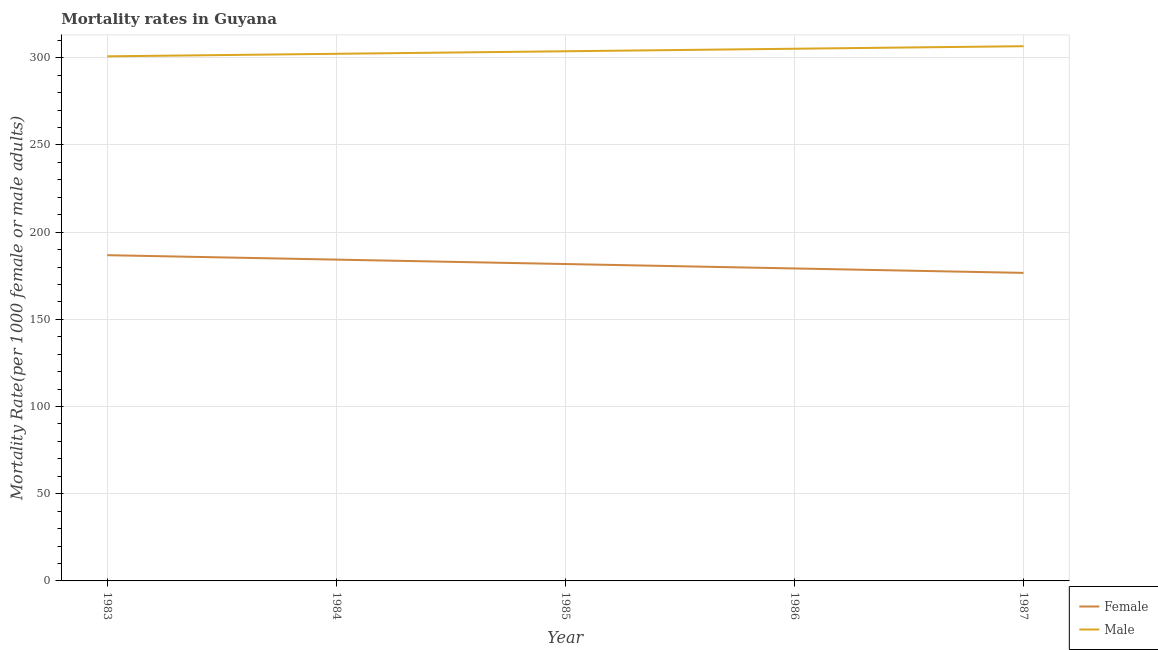How many different coloured lines are there?
Offer a terse response. 2. Is the number of lines equal to the number of legend labels?
Give a very brief answer. Yes. What is the male mortality rate in 1984?
Provide a short and direct response. 302.26. Across all years, what is the maximum male mortality rate?
Provide a succinct answer. 306.62. Across all years, what is the minimum female mortality rate?
Ensure brevity in your answer.  176.64. In which year was the male mortality rate maximum?
Keep it short and to the point. 1987. In which year was the female mortality rate minimum?
Give a very brief answer. 1987. What is the total male mortality rate in the graph?
Your answer should be compact. 1518.56. What is the difference between the female mortality rate in 1984 and that in 1985?
Your response must be concise. 2.53. What is the difference between the male mortality rate in 1984 and the female mortality rate in 1987?
Ensure brevity in your answer.  125.62. What is the average female mortality rate per year?
Your response must be concise. 181.71. In the year 1985, what is the difference between the male mortality rate and female mortality rate?
Keep it short and to the point. 122. What is the ratio of the male mortality rate in 1983 to that in 1985?
Your answer should be very brief. 0.99. Is the difference between the male mortality rate in 1983 and 1987 greater than the difference between the female mortality rate in 1983 and 1987?
Give a very brief answer. No. What is the difference between the highest and the second highest female mortality rate?
Your answer should be very brief. 2.53. What is the difference between the highest and the lowest male mortality rate?
Your answer should be very brief. 5.81. In how many years, is the female mortality rate greater than the average female mortality rate taken over all years?
Offer a very short reply. 3. Does the female mortality rate monotonically increase over the years?
Offer a very short reply. No. How many years are there in the graph?
Keep it short and to the point. 5. Are the values on the major ticks of Y-axis written in scientific E-notation?
Ensure brevity in your answer.  No. Does the graph contain any zero values?
Your response must be concise. No. Does the graph contain grids?
Offer a very short reply. Yes. How are the legend labels stacked?
Your answer should be very brief. Vertical. What is the title of the graph?
Keep it short and to the point. Mortality rates in Guyana. What is the label or title of the X-axis?
Keep it short and to the point. Year. What is the label or title of the Y-axis?
Offer a very short reply. Mortality Rate(per 1000 female or male adults). What is the Mortality Rate(per 1000 female or male adults) of Female in 1983?
Your answer should be compact. 186.78. What is the Mortality Rate(per 1000 female or male adults) of Male in 1983?
Your answer should be very brief. 300.81. What is the Mortality Rate(per 1000 female or male adults) in Female in 1984?
Make the answer very short. 184.25. What is the Mortality Rate(per 1000 female or male adults) of Male in 1984?
Offer a terse response. 302.26. What is the Mortality Rate(per 1000 female or male adults) in Female in 1985?
Keep it short and to the point. 181.71. What is the Mortality Rate(per 1000 female or male adults) in Male in 1985?
Offer a very short reply. 303.71. What is the Mortality Rate(per 1000 female or male adults) in Female in 1986?
Provide a succinct answer. 179.18. What is the Mortality Rate(per 1000 female or male adults) in Male in 1986?
Your response must be concise. 305.17. What is the Mortality Rate(per 1000 female or male adults) of Female in 1987?
Make the answer very short. 176.64. What is the Mortality Rate(per 1000 female or male adults) of Male in 1987?
Provide a succinct answer. 306.62. Across all years, what is the maximum Mortality Rate(per 1000 female or male adults) in Female?
Keep it short and to the point. 186.78. Across all years, what is the maximum Mortality Rate(per 1000 female or male adults) in Male?
Keep it short and to the point. 306.62. Across all years, what is the minimum Mortality Rate(per 1000 female or male adults) of Female?
Provide a succinct answer. 176.64. Across all years, what is the minimum Mortality Rate(per 1000 female or male adults) in Male?
Offer a terse response. 300.81. What is the total Mortality Rate(per 1000 female or male adults) in Female in the graph?
Provide a succinct answer. 908.56. What is the total Mortality Rate(per 1000 female or male adults) of Male in the graph?
Your answer should be compact. 1518.56. What is the difference between the Mortality Rate(per 1000 female or male adults) in Female in 1983 and that in 1984?
Provide a succinct answer. 2.53. What is the difference between the Mortality Rate(per 1000 female or male adults) of Male in 1983 and that in 1984?
Your response must be concise. -1.45. What is the difference between the Mortality Rate(per 1000 female or male adults) in Female in 1983 and that in 1985?
Provide a short and direct response. 5.07. What is the difference between the Mortality Rate(per 1000 female or male adults) of Male in 1983 and that in 1985?
Your answer should be very brief. -2.9. What is the difference between the Mortality Rate(per 1000 female or male adults) of Female in 1983 and that in 1986?
Give a very brief answer. 7.6. What is the difference between the Mortality Rate(per 1000 female or male adults) in Male in 1983 and that in 1986?
Provide a succinct answer. -4.36. What is the difference between the Mortality Rate(per 1000 female or male adults) in Female in 1983 and that in 1987?
Provide a short and direct response. 10.14. What is the difference between the Mortality Rate(per 1000 female or male adults) of Male in 1983 and that in 1987?
Your answer should be compact. -5.81. What is the difference between the Mortality Rate(per 1000 female or male adults) of Female in 1984 and that in 1985?
Provide a short and direct response. 2.53. What is the difference between the Mortality Rate(per 1000 female or male adults) in Male in 1984 and that in 1985?
Make the answer very short. -1.45. What is the difference between the Mortality Rate(per 1000 female or male adults) in Female in 1984 and that in 1986?
Provide a succinct answer. 5.07. What is the difference between the Mortality Rate(per 1000 female or male adults) in Male in 1984 and that in 1986?
Provide a succinct answer. -2.9. What is the difference between the Mortality Rate(per 1000 female or male adults) of Female in 1984 and that in 1987?
Your answer should be very brief. 7.6. What is the difference between the Mortality Rate(per 1000 female or male adults) in Male in 1984 and that in 1987?
Provide a short and direct response. -4.36. What is the difference between the Mortality Rate(per 1000 female or male adults) of Female in 1985 and that in 1986?
Offer a very short reply. 2.54. What is the difference between the Mortality Rate(per 1000 female or male adults) of Male in 1985 and that in 1986?
Provide a succinct answer. -1.45. What is the difference between the Mortality Rate(per 1000 female or male adults) of Female in 1985 and that in 1987?
Offer a terse response. 5.07. What is the difference between the Mortality Rate(per 1000 female or male adults) of Male in 1985 and that in 1987?
Ensure brevity in your answer.  -2.9. What is the difference between the Mortality Rate(per 1000 female or male adults) in Female in 1986 and that in 1987?
Your answer should be very brief. 2.53. What is the difference between the Mortality Rate(per 1000 female or male adults) of Male in 1986 and that in 1987?
Make the answer very short. -1.45. What is the difference between the Mortality Rate(per 1000 female or male adults) of Female in 1983 and the Mortality Rate(per 1000 female or male adults) of Male in 1984?
Make the answer very short. -115.48. What is the difference between the Mortality Rate(per 1000 female or male adults) in Female in 1983 and the Mortality Rate(per 1000 female or male adults) in Male in 1985?
Your answer should be compact. -116.93. What is the difference between the Mortality Rate(per 1000 female or male adults) of Female in 1983 and the Mortality Rate(per 1000 female or male adults) of Male in 1986?
Give a very brief answer. -118.38. What is the difference between the Mortality Rate(per 1000 female or male adults) of Female in 1983 and the Mortality Rate(per 1000 female or male adults) of Male in 1987?
Ensure brevity in your answer.  -119.83. What is the difference between the Mortality Rate(per 1000 female or male adults) of Female in 1984 and the Mortality Rate(per 1000 female or male adults) of Male in 1985?
Offer a terse response. -119.47. What is the difference between the Mortality Rate(per 1000 female or male adults) of Female in 1984 and the Mortality Rate(per 1000 female or male adults) of Male in 1986?
Your response must be concise. -120.92. What is the difference between the Mortality Rate(per 1000 female or male adults) of Female in 1984 and the Mortality Rate(per 1000 female or male adults) of Male in 1987?
Your response must be concise. -122.37. What is the difference between the Mortality Rate(per 1000 female or male adults) of Female in 1985 and the Mortality Rate(per 1000 female or male adults) of Male in 1986?
Provide a short and direct response. -123.45. What is the difference between the Mortality Rate(per 1000 female or male adults) of Female in 1985 and the Mortality Rate(per 1000 female or male adults) of Male in 1987?
Make the answer very short. -124.9. What is the difference between the Mortality Rate(per 1000 female or male adults) in Female in 1986 and the Mortality Rate(per 1000 female or male adults) in Male in 1987?
Keep it short and to the point. -127.44. What is the average Mortality Rate(per 1000 female or male adults) of Female per year?
Ensure brevity in your answer.  181.71. What is the average Mortality Rate(per 1000 female or male adults) of Male per year?
Give a very brief answer. 303.71. In the year 1983, what is the difference between the Mortality Rate(per 1000 female or male adults) in Female and Mortality Rate(per 1000 female or male adults) in Male?
Provide a short and direct response. -114.03. In the year 1984, what is the difference between the Mortality Rate(per 1000 female or male adults) of Female and Mortality Rate(per 1000 female or male adults) of Male?
Make the answer very short. -118.01. In the year 1985, what is the difference between the Mortality Rate(per 1000 female or male adults) in Female and Mortality Rate(per 1000 female or male adults) in Male?
Your response must be concise. -122. In the year 1986, what is the difference between the Mortality Rate(per 1000 female or male adults) in Female and Mortality Rate(per 1000 female or male adults) in Male?
Your response must be concise. -125.99. In the year 1987, what is the difference between the Mortality Rate(per 1000 female or male adults) of Female and Mortality Rate(per 1000 female or male adults) of Male?
Your response must be concise. -129.97. What is the ratio of the Mortality Rate(per 1000 female or male adults) of Female in 1983 to that in 1984?
Offer a very short reply. 1.01. What is the ratio of the Mortality Rate(per 1000 female or male adults) in Female in 1983 to that in 1985?
Offer a very short reply. 1.03. What is the ratio of the Mortality Rate(per 1000 female or male adults) of Male in 1983 to that in 1985?
Provide a short and direct response. 0.99. What is the ratio of the Mortality Rate(per 1000 female or male adults) of Female in 1983 to that in 1986?
Provide a succinct answer. 1.04. What is the ratio of the Mortality Rate(per 1000 female or male adults) of Male in 1983 to that in 1986?
Your answer should be very brief. 0.99. What is the ratio of the Mortality Rate(per 1000 female or male adults) in Female in 1983 to that in 1987?
Offer a terse response. 1.06. What is the ratio of the Mortality Rate(per 1000 female or male adults) of Male in 1983 to that in 1987?
Keep it short and to the point. 0.98. What is the ratio of the Mortality Rate(per 1000 female or male adults) in Female in 1984 to that in 1985?
Keep it short and to the point. 1.01. What is the ratio of the Mortality Rate(per 1000 female or male adults) in Male in 1984 to that in 1985?
Make the answer very short. 1. What is the ratio of the Mortality Rate(per 1000 female or male adults) of Female in 1984 to that in 1986?
Offer a terse response. 1.03. What is the ratio of the Mortality Rate(per 1000 female or male adults) in Female in 1984 to that in 1987?
Make the answer very short. 1.04. What is the ratio of the Mortality Rate(per 1000 female or male adults) of Male in 1984 to that in 1987?
Ensure brevity in your answer.  0.99. What is the ratio of the Mortality Rate(per 1000 female or male adults) in Female in 1985 to that in 1986?
Make the answer very short. 1.01. What is the ratio of the Mortality Rate(per 1000 female or male adults) of Female in 1985 to that in 1987?
Offer a very short reply. 1.03. What is the ratio of the Mortality Rate(per 1000 female or male adults) of Male in 1985 to that in 1987?
Provide a succinct answer. 0.99. What is the ratio of the Mortality Rate(per 1000 female or male adults) of Female in 1986 to that in 1987?
Offer a terse response. 1.01. What is the difference between the highest and the second highest Mortality Rate(per 1000 female or male adults) in Female?
Make the answer very short. 2.53. What is the difference between the highest and the second highest Mortality Rate(per 1000 female or male adults) in Male?
Keep it short and to the point. 1.45. What is the difference between the highest and the lowest Mortality Rate(per 1000 female or male adults) in Female?
Keep it short and to the point. 10.14. What is the difference between the highest and the lowest Mortality Rate(per 1000 female or male adults) of Male?
Your answer should be compact. 5.81. 